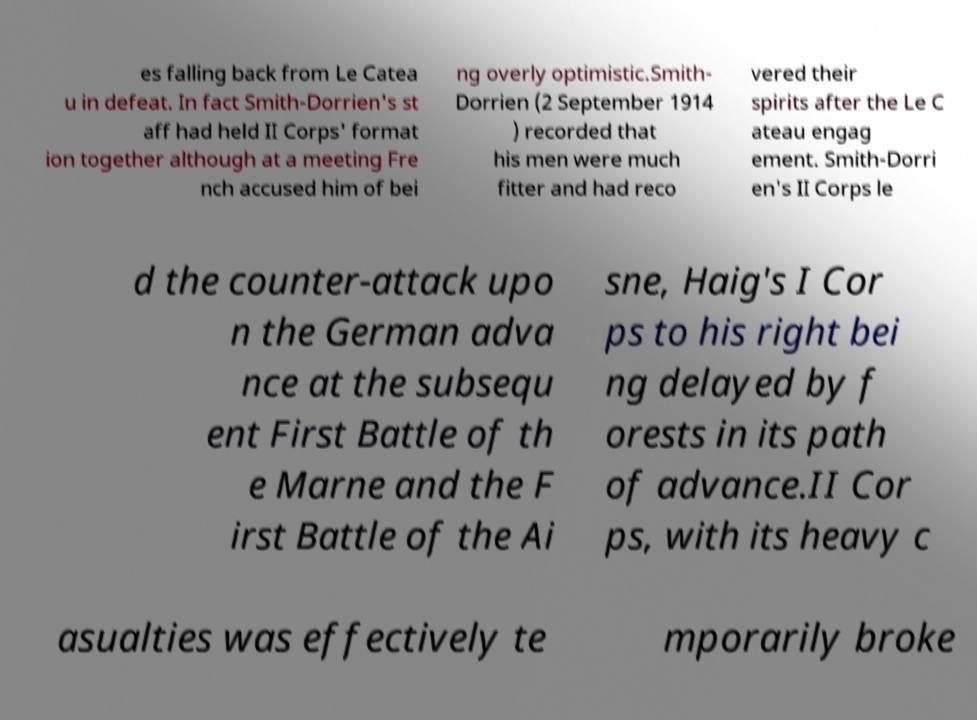Please read and relay the text visible in this image. What does it say? es falling back from Le Catea u in defeat. In fact Smith-Dorrien's st aff had held II Corps' format ion together although at a meeting Fre nch accused him of bei ng overly optimistic.Smith- Dorrien (2 September 1914 ) recorded that his men were much fitter and had reco vered their spirits after the Le C ateau engag ement. Smith-Dorri en's II Corps le d the counter-attack upo n the German adva nce at the subsequ ent First Battle of th e Marne and the F irst Battle of the Ai sne, Haig's I Cor ps to his right bei ng delayed by f orests in its path of advance.II Cor ps, with its heavy c asualties was effectively te mporarily broke 